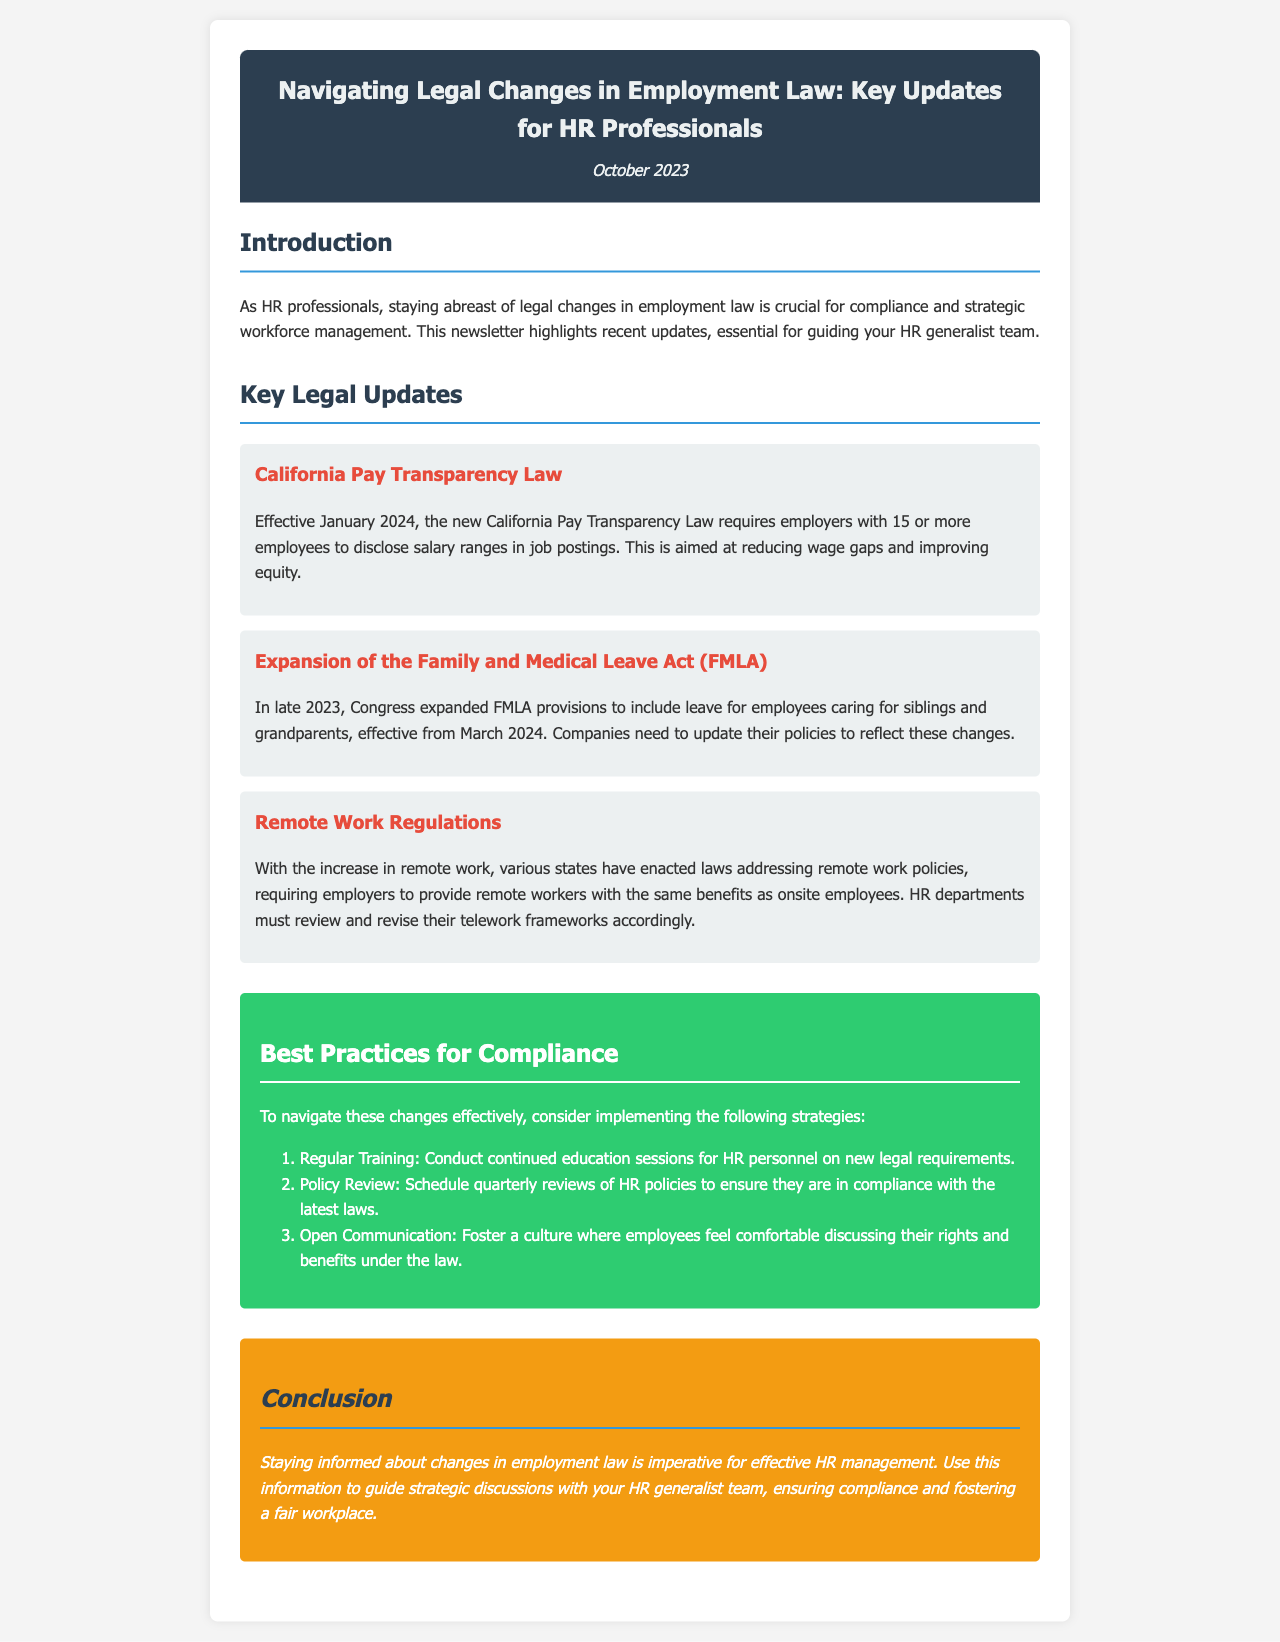What is the title of the newsletter? The title of the newsletter is stated in the header section of the document.
Answer: Navigating Legal Changes in Employment Law: Key Updates for HR Professionals What is the date of publication? The date is mentioned right below the title in the header.
Answer: October 2023 What law will take effect in January 2024? The specific law is listed under the key legal updates section.
Answer: California Pay Transparency Law What does the expanded FMLA provisions include? This is mentioned in the description of the FMLA update.
Answer: Leave for employees caring for siblings and grandparents When will remote work regulations require employers to comply? This is discussed in the remote work section of the document.
Answer: Various states How many best practice strategies are suggested for compliance? The number of strategies is indicated in the best practices section.
Answer: Three What is one suggested best practice for HR compliance? This detail is listed in the best practices section.
Answer: Regular Training What color is used for the conclusion section? The specific color is referenced in the styling of the conclusion.
Answer: Orange 